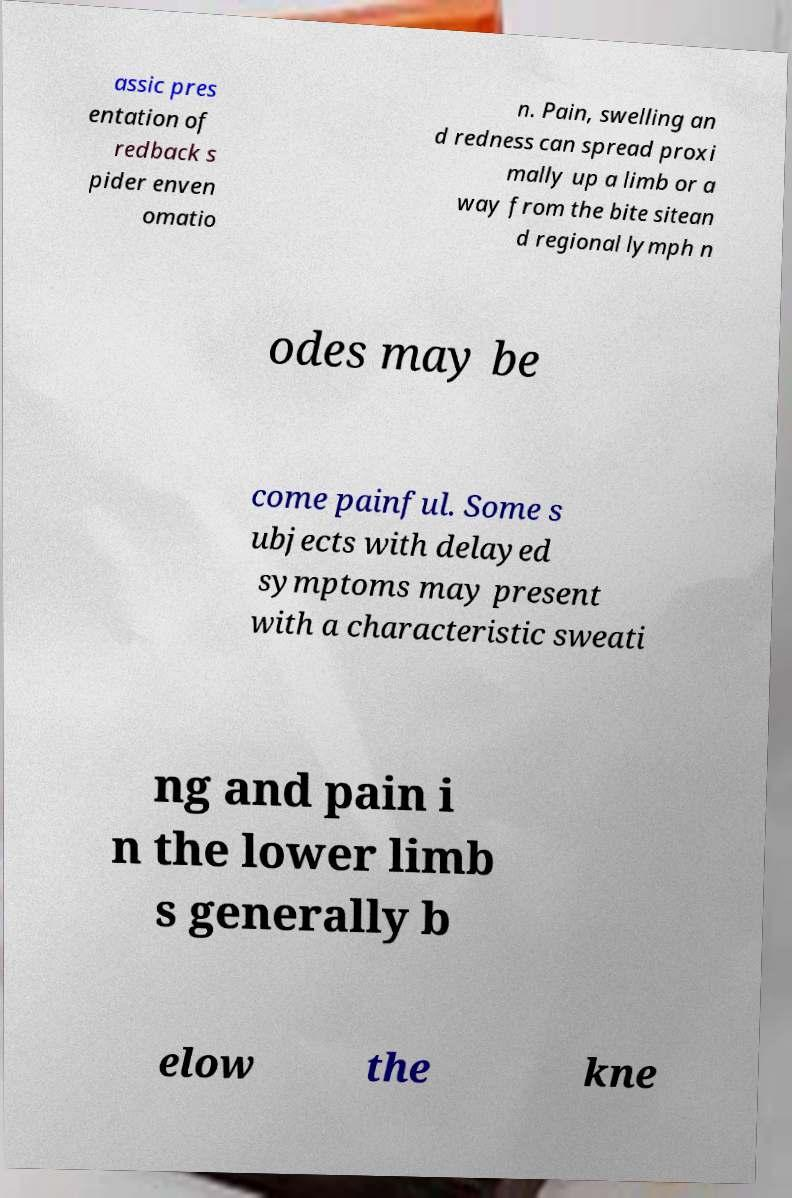Could you assist in decoding the text presented in this image and type it out clearly? assic pres entation of redback s pider enven omatio n. Pain, swelling an d redness can spread proxi mally up a limb or a way from the bite sitean d regional lymph n odes may be come painful. Some s ubjects with delayed symptoms may present with a characteristic sweati ng and pain i n the lower limb s generally b elow the kne 